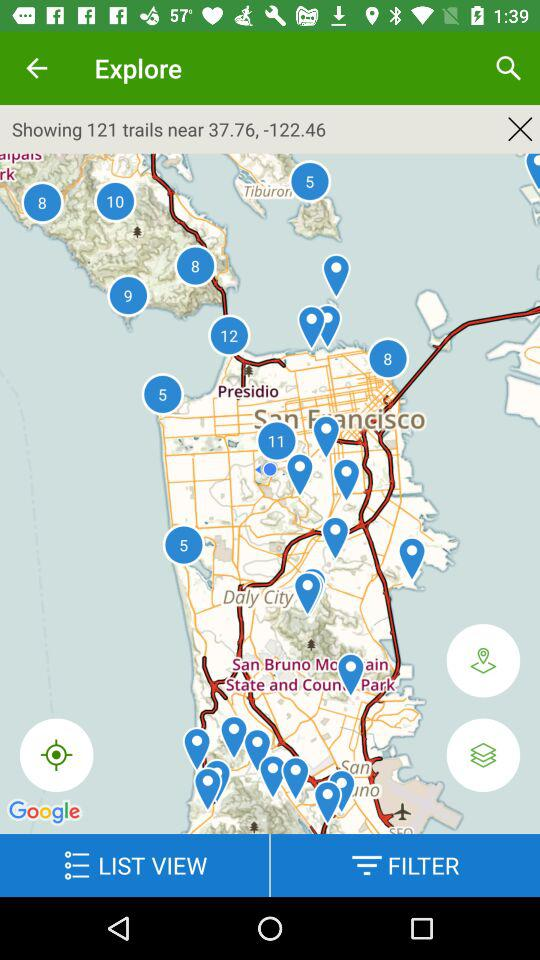How many more trails are shown than filters?
Answer the question using a single word or phrase. 121 